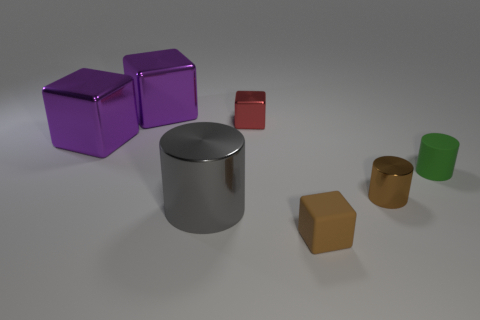Subtract all large cylinders. How many cylinders are left? 2 Add 2 small blue metal cylinders. How many objects exist? 9 Subtract all red blocks. How many blocks are left? 3 Subtract all cylinders. How many objects are left? 4 Subtract all brown cylinders. How many purple blocks are left? 2 Subtract 0 green cubes. How many objects are left? 7 Subtract 2 cylinders. How many cylinders are left? 1 Subtract all blue cubes. Subtract all red spheres. How many cubes are left? 4 Subtract all big gray metallic cylinders. Subtract all big gray things. How many objects are left? 5 Add 2 metal objects. How many metal objects are left? 7 